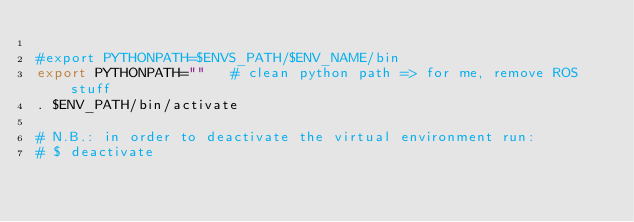<code> <loc_0><loc_0><loc_500><loc_500><_Bash_>
#export PYTHONPATH=$ENVS_PATH/$ENV_NAME/bin  
export PYTHONPATH=""   # clean python path => for me, remove ROS stuff 
. $ENV_PATH/bin/activate  

# N.B.: in order to deactivate the virtual environment run: 
# $ deactivate 
</code> 